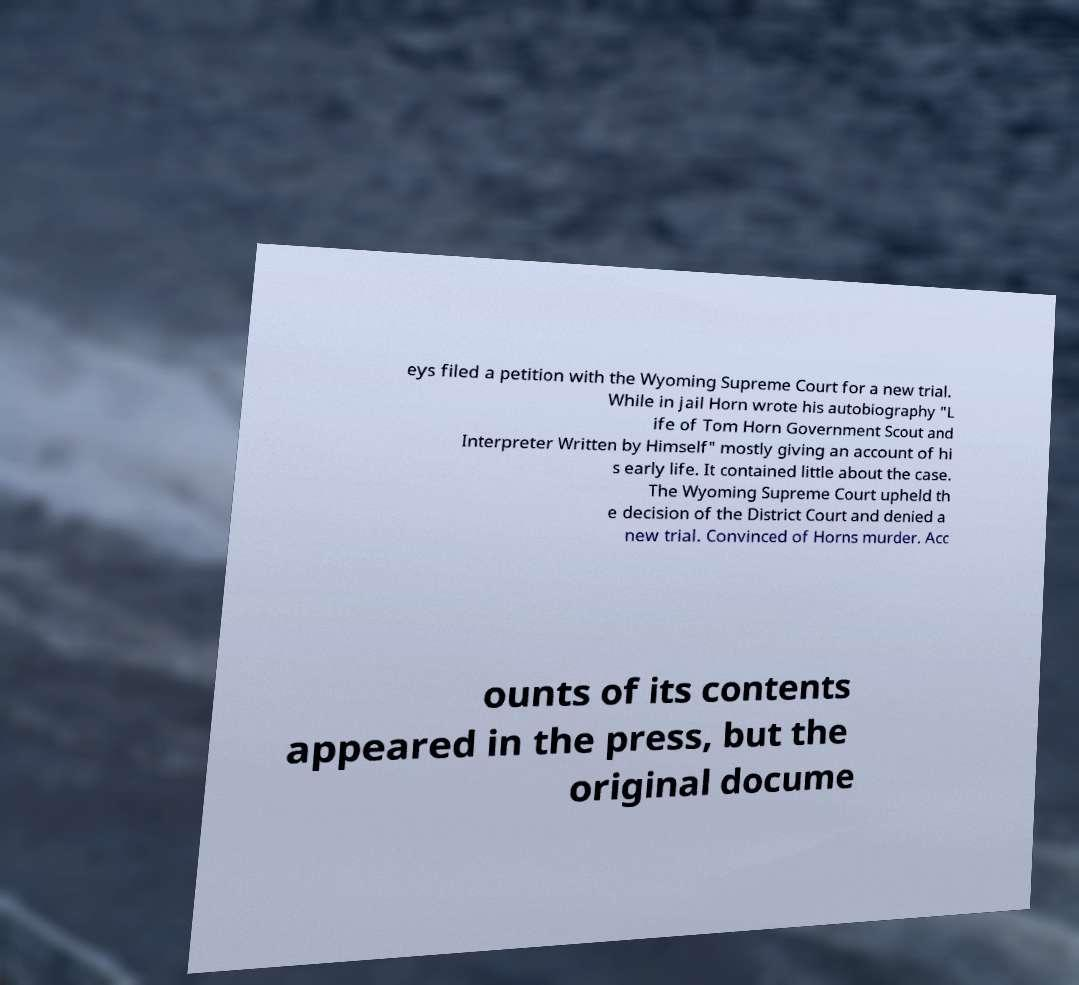There's text embedded in this image that I need extracted. Can you transcribe it verbatim? eys filed a petition with the Wyoming Supreme Court for a new trial. While in jail Horn wrote his autobiography "L ife of Tom Horn Government Scout and Interpreter Written by Himself" mostly giving an account of hi s early life. It contained little about the case. The Wyoming Supreme Court upheld th e decision of the District Court and denied a new trial. Convinced of Horns murder. Acc ounts of its contents appeared in the press, but the original docume 